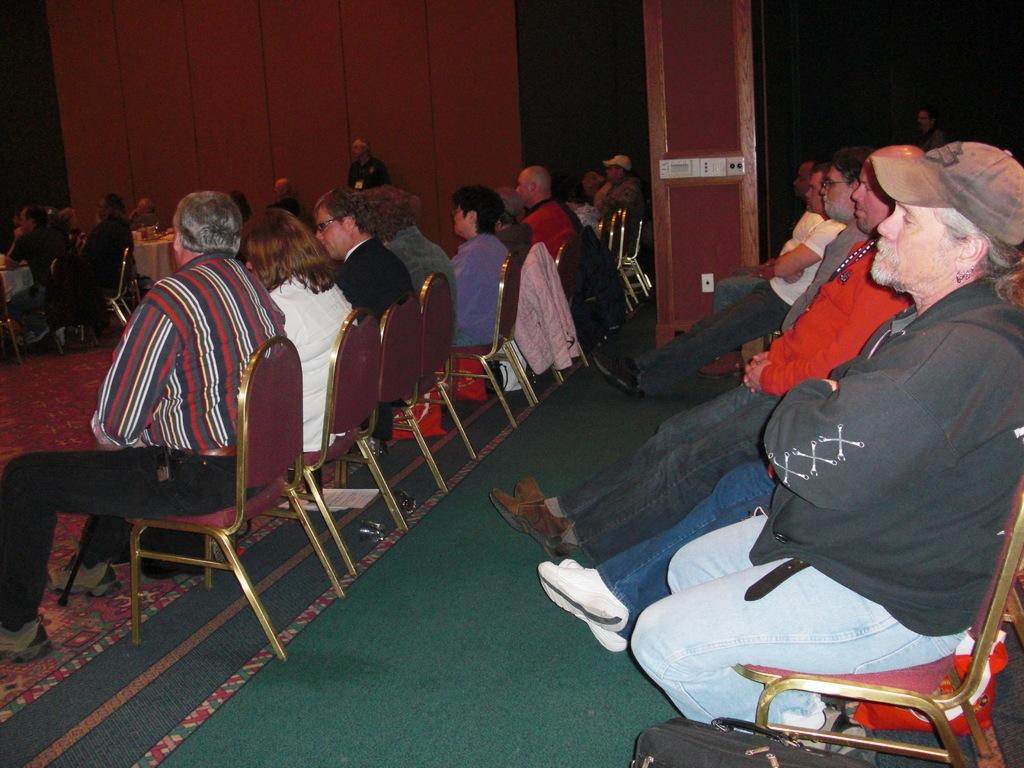How many persons are in the image? There are persons in the image, but the exact number is not specified. What are the persons wearing? The persons are wearing clothes. What are the persons doing in the image? The persons are sitting on chairs. What is visible at the top of the image? There is a wall at the top of the image. What is present at the bottom of the image? There is a bag at the bottom of the image. What type of scarf is the fish wearing in the image? There is no fish or scarf present in the image. How many children does the mother have in the image? There is no mention of a mother or children in the image. 